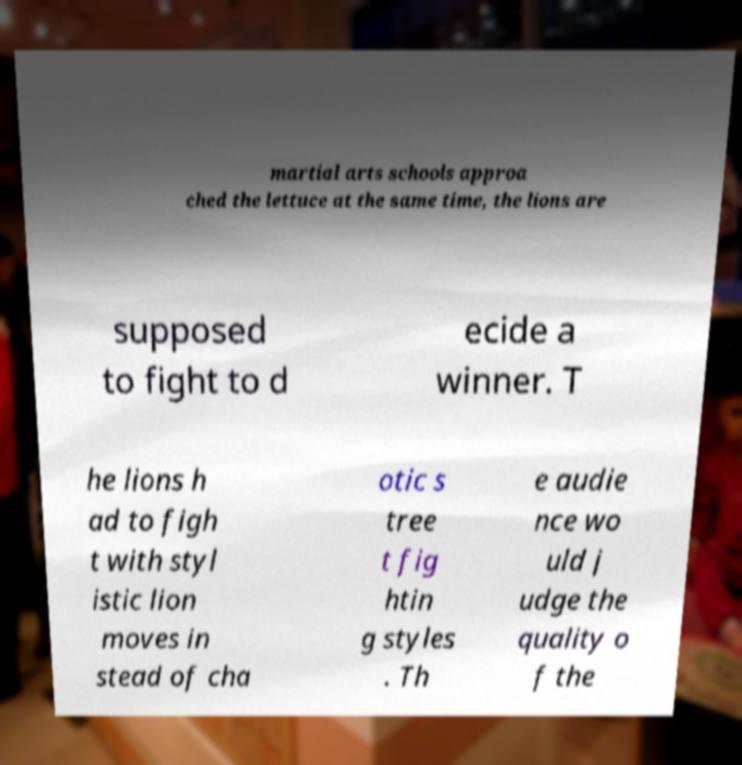What messages or text are displayed in this image? I need them in a readable, typed format. martial arts schools approa ched the lettuce at the same time, the lions are supposed to fight to d ecide a winner. T he lions h ad to figh t with styl istic lion moves in stead of cha otic s tree t fig htin g styles . Th e audie nce wo uld j udge the quality o f the 